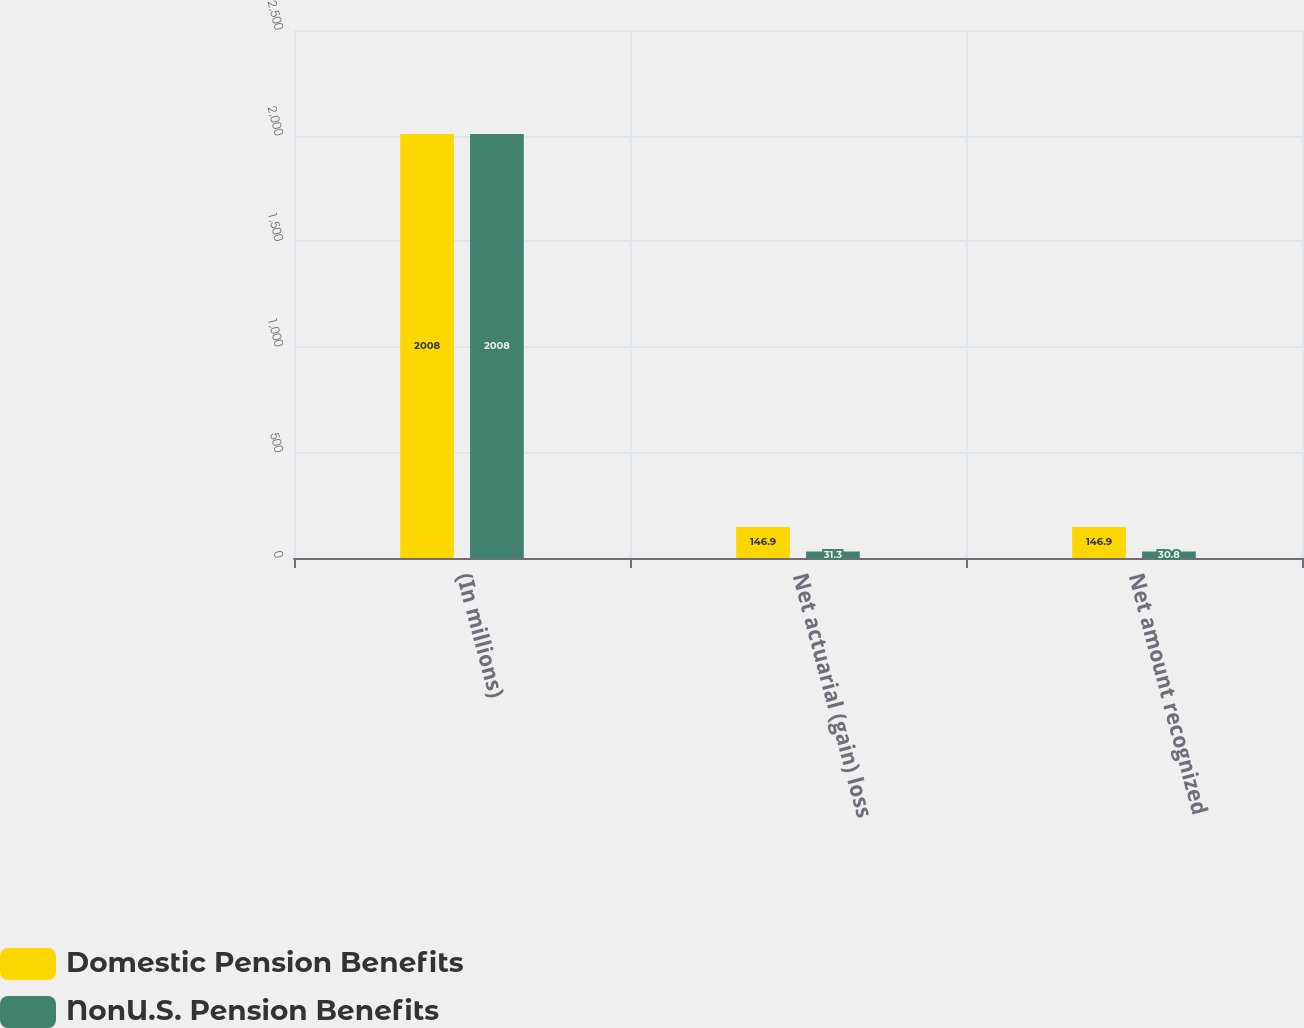Convert chart to OTSL. <chart><loc_0><loc_0><loc_500><loc_500><stacked_bar_chart><ecel><fcel>(In millions)<fcel>Net actuarial (gain) loss<fcel>Net amount recognized<nl><fcel>Domestic Pension Benefits<fcel>2008<fcel>146.9<fcel>146.9<nl><fcel>NonU.S. Pension Benefits<fcel>2008<fcel>31.3<fcel>30.8<nl></chart> 